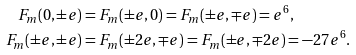Convert formula to latex. <formula><loc_0><loc_0><loc_500><loc_500>F _ { m } ( 0 , \pm e ) & = F _ { m } ( \pm e , 0 ) = F _ { m } ( \pm e , \mp e ) = e ^ { 6 } , \\ F _ { m } ( \pm e , \pm e ) & = F _ { m } ( \pm 2 e , \mp e ) = F _ { m } ( \pm e , \mp 2 e ) = - 2 7 e ^ { 6 } .</formula> 